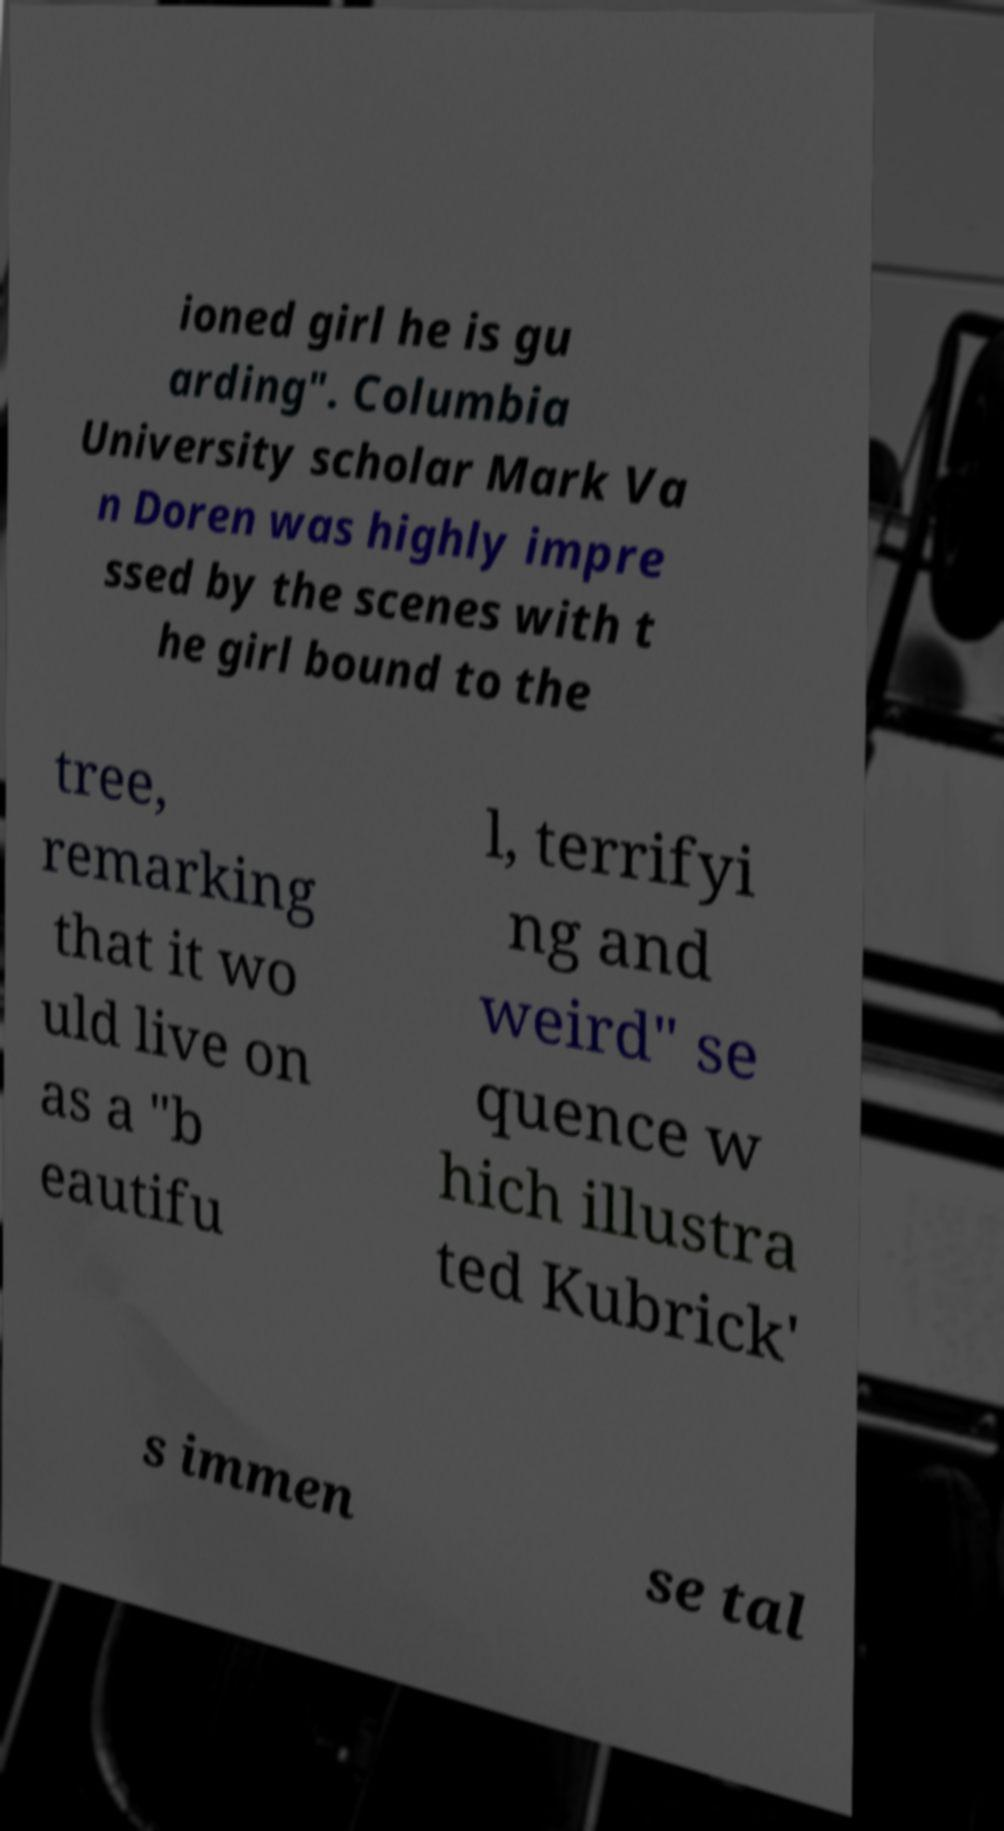I need the written content from this picture converted into text. Can you do that? ioned girl he is gu arding". Columbia University scholar Mark Va n Doren was highly impre ssed by the scenes with t he girl bound to the tree, remarking that it wo uld live on as a "b eautifu l, terrifyi ng and weird" se quence w hich illustra ted Kubrick' s immen se tal 